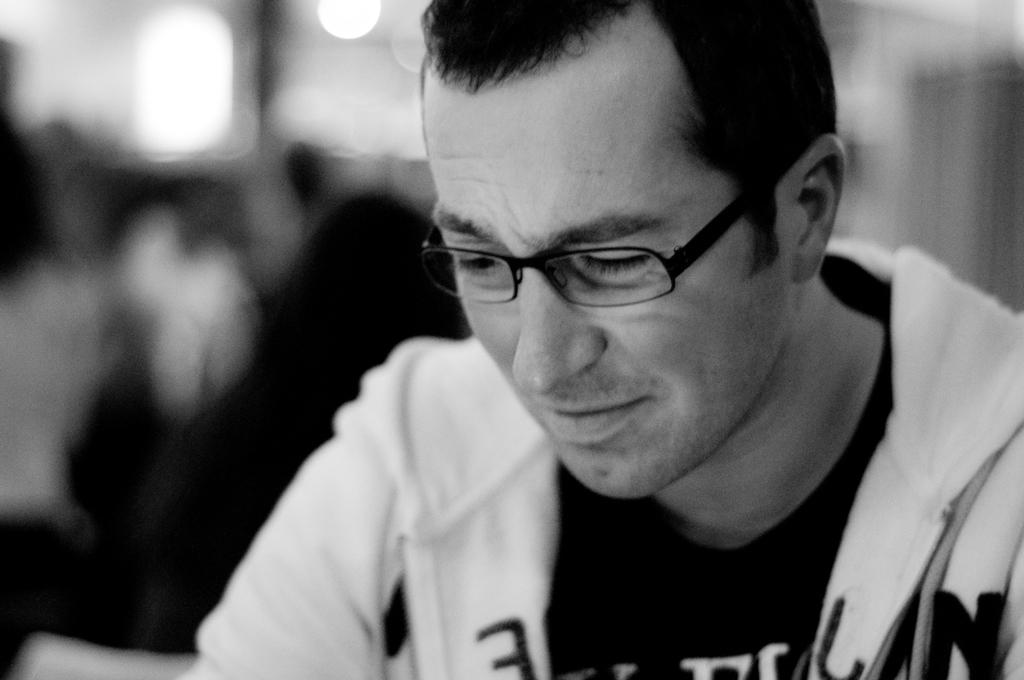Who is present in the image? There is a man in the image. What is the man's facial expression? The man is smiling. What accessory is the man wearing? The man is wearing spectacles. Can you describe the background of the image? The background of the image is blurred. What type of work is the man doing in the image? There is no indication of work being done in the image. The man is simply smiling and wearing spectacles. 